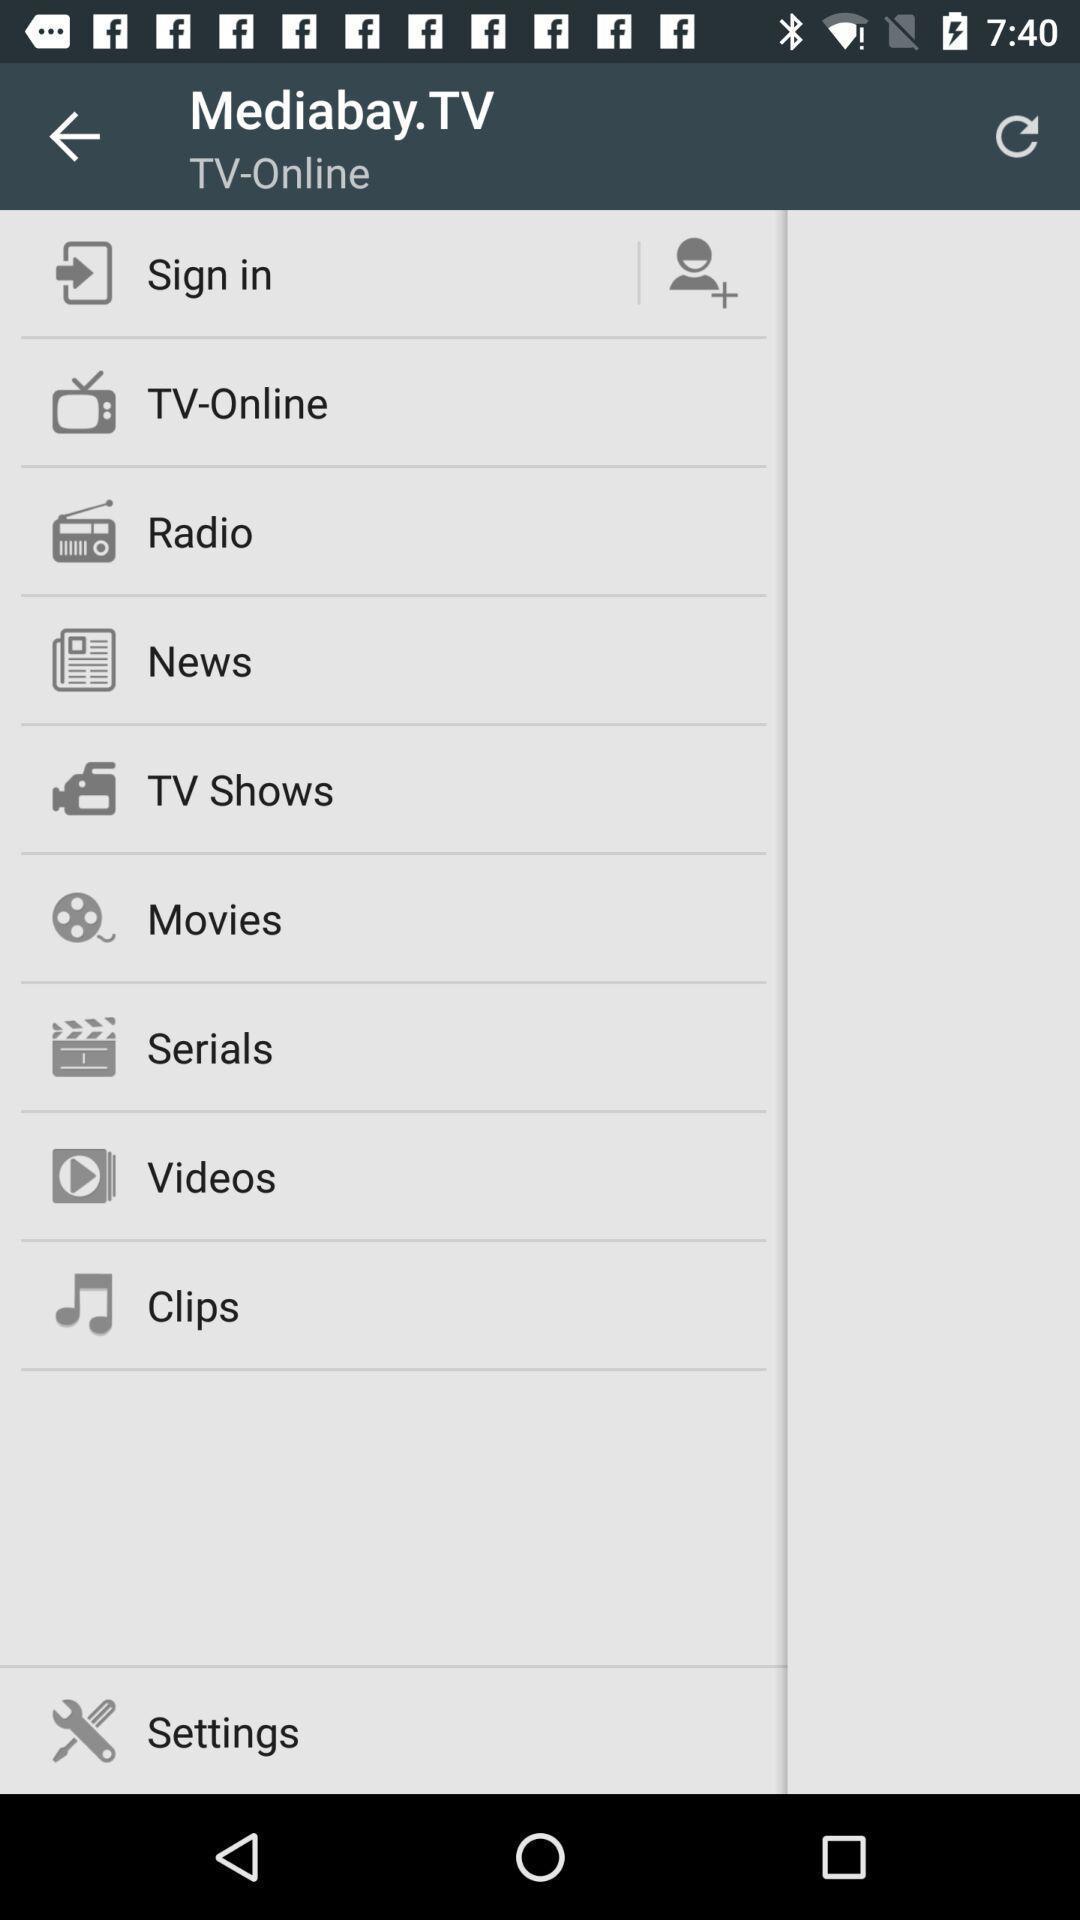Provide a description of this screenshot. Sign in page. 